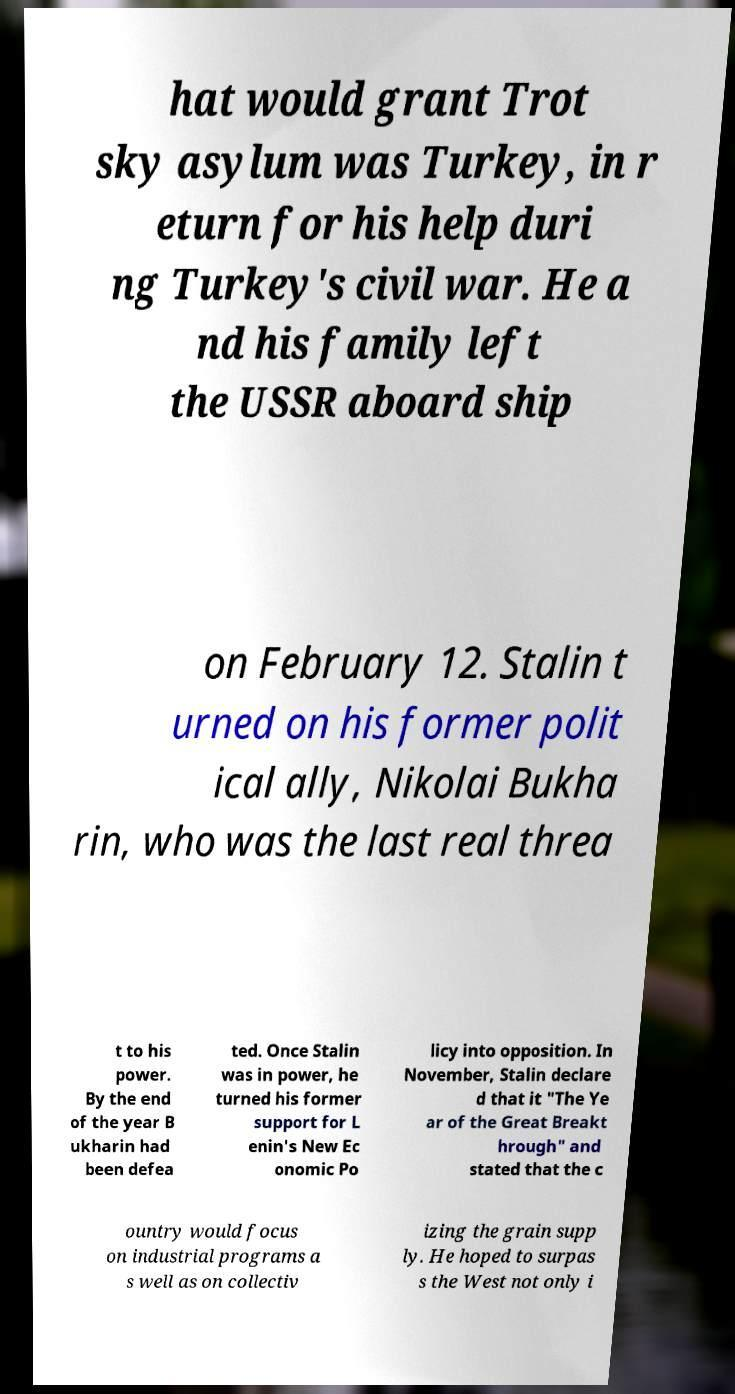Can you read and provide the text displayed in the image?This photo seems to have some interesting text. Can you extract and type it out for me? hat would grant Trot sky asylum was Turkey, in r eturn for his help duri ng Turkey's civil war. He a nd his family left the USSR aboard ship on February 12. Stalin t urned on his former polit ical ally, Nikolai Bukha rin, who was the last real threa t to his power. By the end of the year B ukharin had been defea ted. Once Stalin was in power, he turned his former support for L enin's New Ec onomic Po licy into opposition. In November, Stalin declare d that it "The Ye ar of the Great Breakt hrough" and stated that the c ountry would focus on industrial programs a s well as on collectiv izing the grain supp ly. He hoped to surpas s the West not only i 